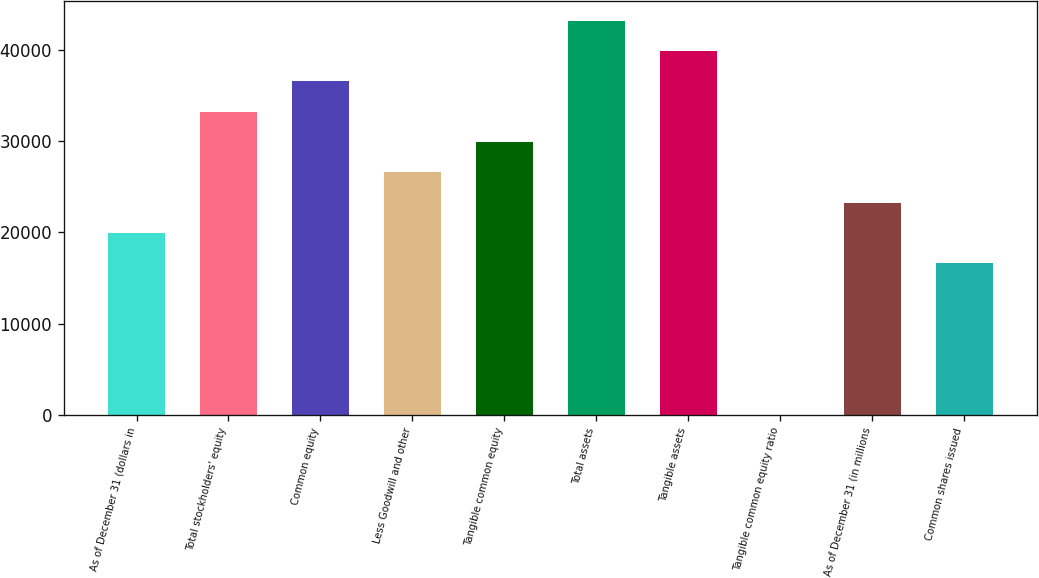<chart> <loc_0><loc_0><loc_500><loc_500><bar_chart><fcel>As of December 31 (dollars in<fcel>Total stockholders' equity<fcel>Common equity<fcel>Less Goodwill and other<fcel>Tangible common equity<fcel>Total assets<fcel>Tangible assets<fcel>Tangible common equity ratio<fcel>As of December 31 (in millions<fcel>Common shares issued<nl><fcel>19934.6<fcel>33219<fcel>36540.1<fcel>26576.8<fcel>29897.9<fcel>43182.3<fcel>39861.2<fcel>7.9<fcel>23255.7<fcel>16613.5<nl></chart> 